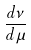<formula> <loc_0><loc_0><loc_500><loc_500>\frac { d \nu } { d \mu }</formula> 